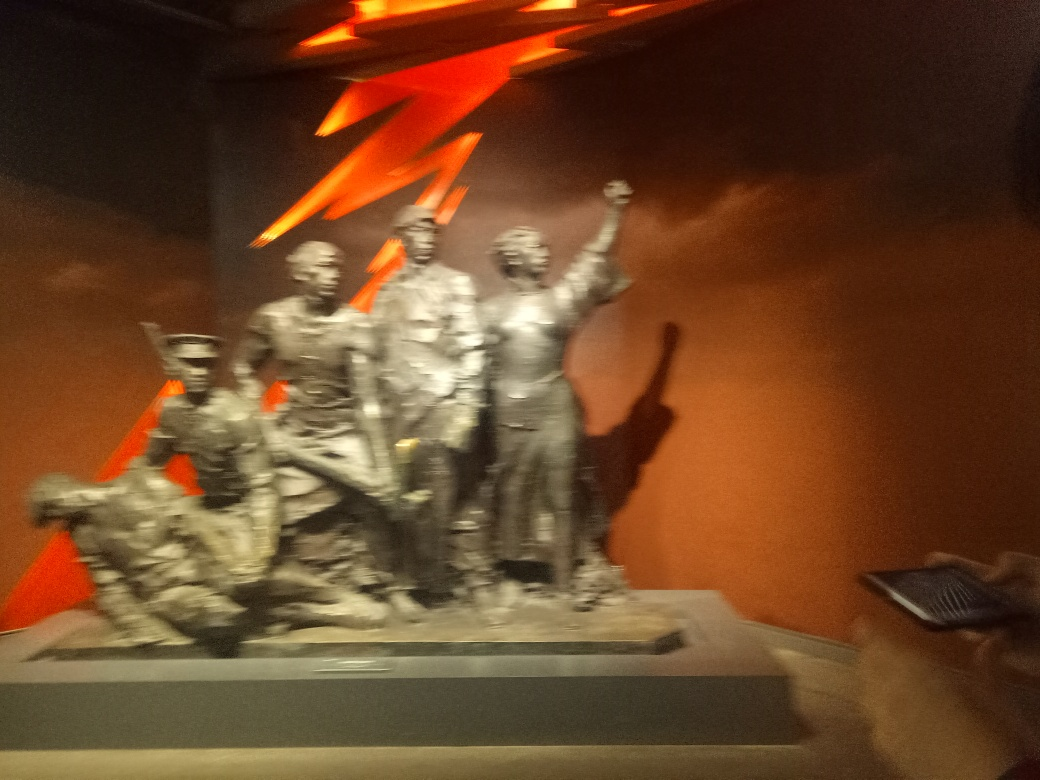Are the details of the subject clear? The image shows a blurry sculpture of multiple figures, which impedes the ability to discern fine details. It appears to capture a moment of dynamic activity or celebration. For a clearer understanding, a more focused and well-lit photograph would be beneficial. 